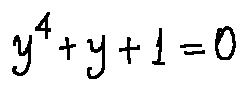Convert formula to latex. <formula><loc_0><loc_0><loc_500><loc_500>y ^ { 4 } + y + 1 = 0</formula> 